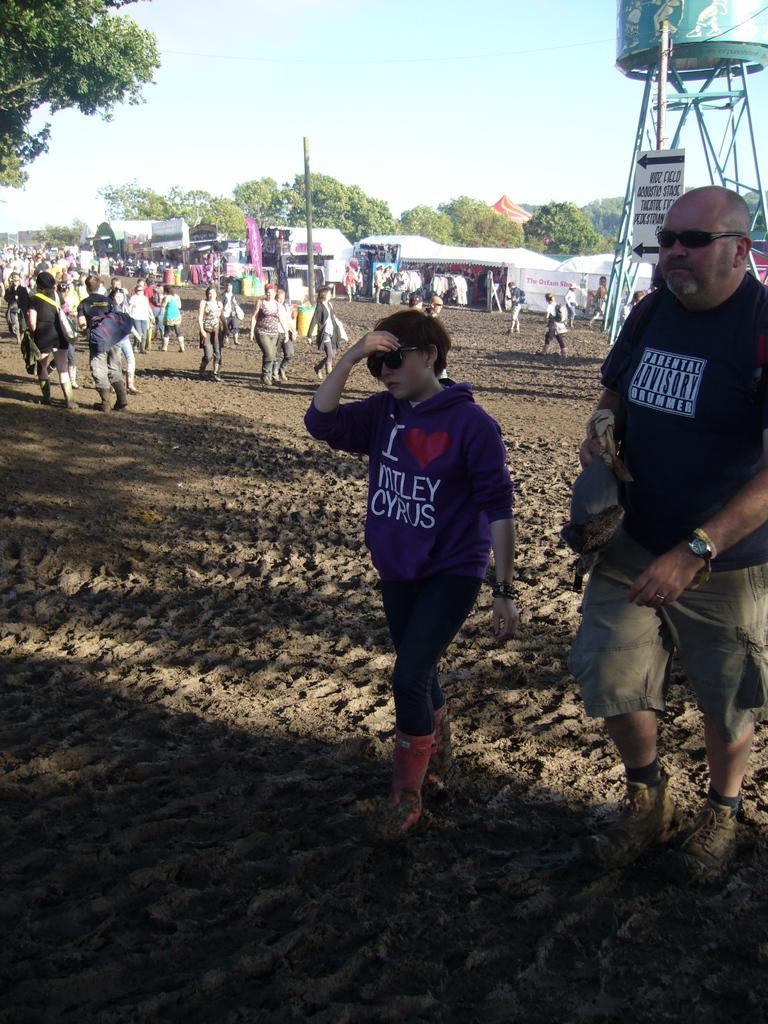In one or two sentences, can you explain what this image depicts? In this image there are people are walking on a sand land, in the background there is a water tank , tents, trees and a sky. 